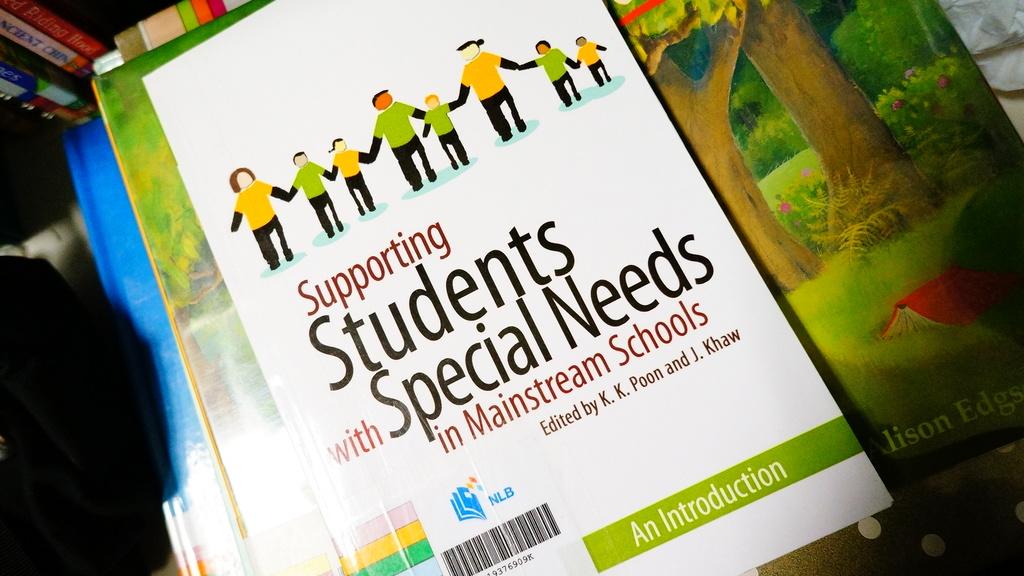What kind of students are deiscuseed?
Your answer should be very brief. Special needs. 